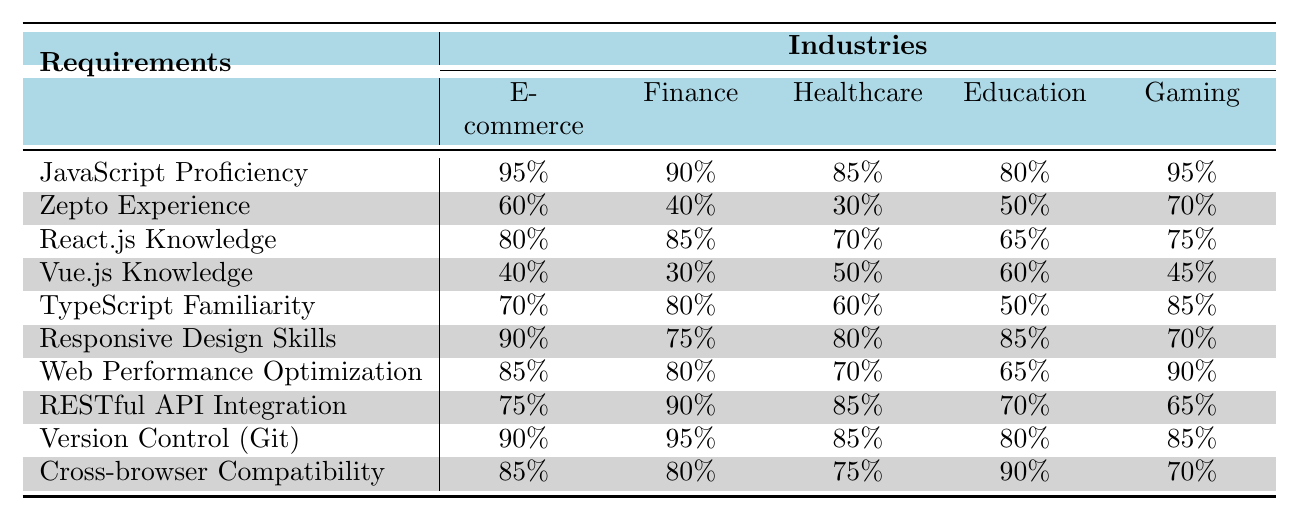What industry has the highest requirement for JavaScript Proficiency? The value for JavaScript Proficiency is 95% for both E-commerce and Gaming, making them the industries with the highest requirement.
Answer: E-commerce and Gaming Which industry has the lowest percentage for React.js Knowledge? From the table, the Healthcare industry has the lowest percentage of 70% for React.js Knowledge when comparing all listed industries.
Answer: Healthcare What is the average percentage of Zepto Experience across all industries? The percentages for Zepto Experience are 60%, 40%, 30%, 50%, and 70%. The sum is 60 + 40 + 30 + 50 + 70 = 250, and there are 5 industries, so the average is 250/5 = 50%.
Answer: 50% Is it true that Education has higher requirements for Cross-browser Compatibility than Gaming? Education has a requirement of 90% for Cross-browser Compatibility, whereas Gaming has a requirement of 70%. Thus, it is true that Education has a higher requirement.
Answer: True Which industry shows the largest discrepancy between Web Performance Optimization and RESTful API Integration? The largest discrepancy is for Gaming at 90% (Web Performance Optimization) and 65% (RESTful API Integration), resulting in a difference of 90 - 65 = 25%.
Answer: 25% How does the requirement for TypeScript Familiarity compare between E-commerce and Finance? E-commerce has a requirement of 70% for TypeScript Familiarity, while Finance has 80%. Therefore, Finance has a higher requirement by 10%.
Answer: Finance, by 10% Which industry requires the least Responsive Design Skills? Healthcare requires 80% for Responsive Design Skills, which is the lowest among all the industries listed.
Answer: Healthcare Count the number of industries that require at least 85% for Web Performance Optimization. E-commerce and Gaming both require 90% and 90%, respectively, while Finance requires 80%. Therefore, only two industries meet the criteria of at least 85%.
Answer: 2 Which requirement has the same percentage in both E-commerce and Gaming? Both E-commerce and Gaming require 90% for Responsive Design Skills, and they also match on Version Control (Git) at 85%. So, both requirements can be considered.
Answer: Responsive Design Skills and Version Control (Git) What is the percentage difference between the highest and lowest requirement for Cross-browser Compatibility? The highest requirement is 90% in Education and the lowest is 70% in Gaming, which results in a difference of 90 - 70 = 20%.
Answer: 20% 